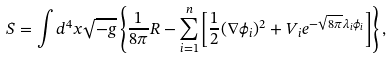<formula> <loc_0><loc_0><loc_500><loc_500>S = \int d ^ { 4 } x \sqrt { - g } \left \{ \frac { 1 } { 8 \pi } R - \sum ^ { n } _ { i = 1 } \left [ \frac { 1 } { 2 } ( \nabla \phi _ { i } ) ^ { 2 } + V _ { i } e ^ { - \sqrt { 8 \pi } \lambda _ { i } \phi _ { i } } \right ] \right \} ,</formula> 